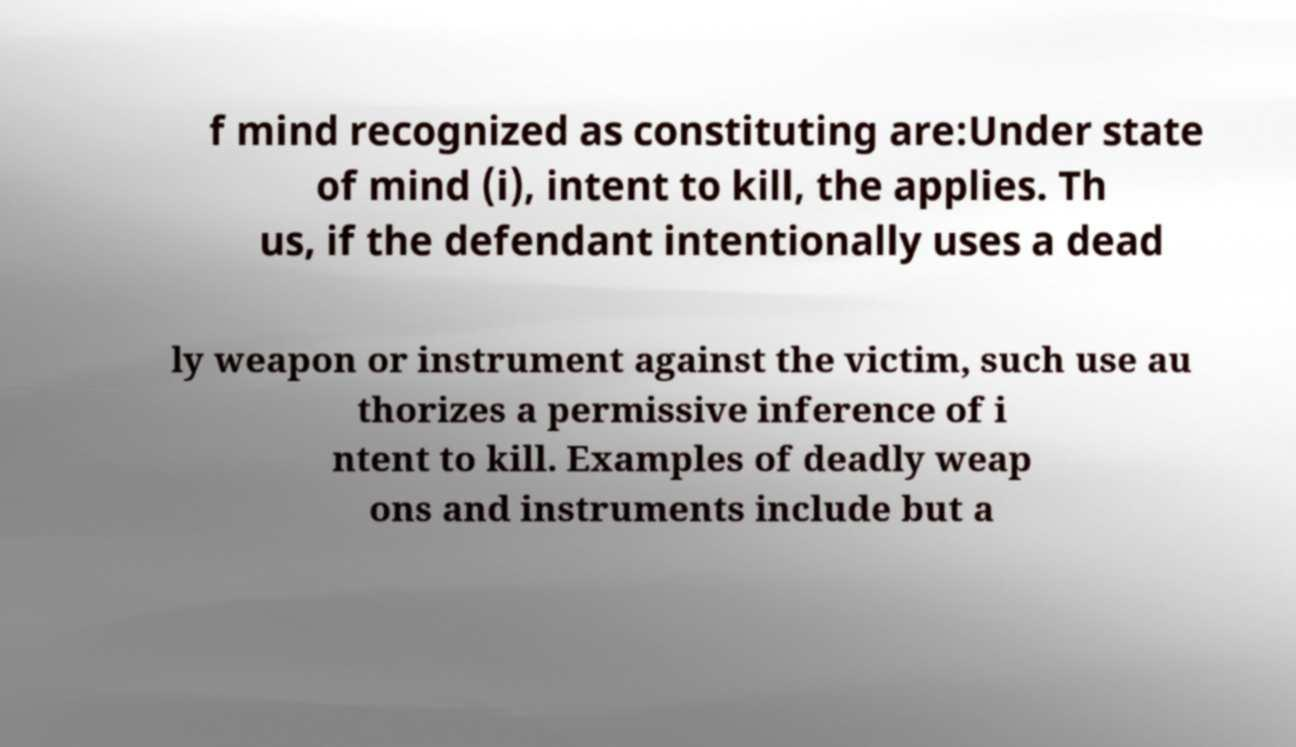Could you extract and type out the text from this image? f mind recognized as constituting are:Under state of mind (i), intent to kill, the applies. Th us, if the defendant intentionally uses a dead ly weapon or instrument against the victim, such use au thorizes a permissive inference of i ntent to kill. Examples of deadly weap ons and instruments include but a 